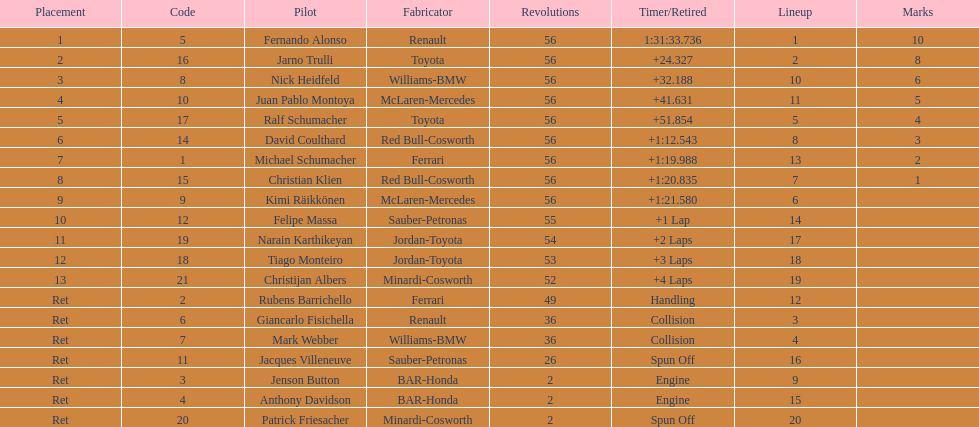What was the aggregate number of laps concluded by the 1st rank winner? 56. 